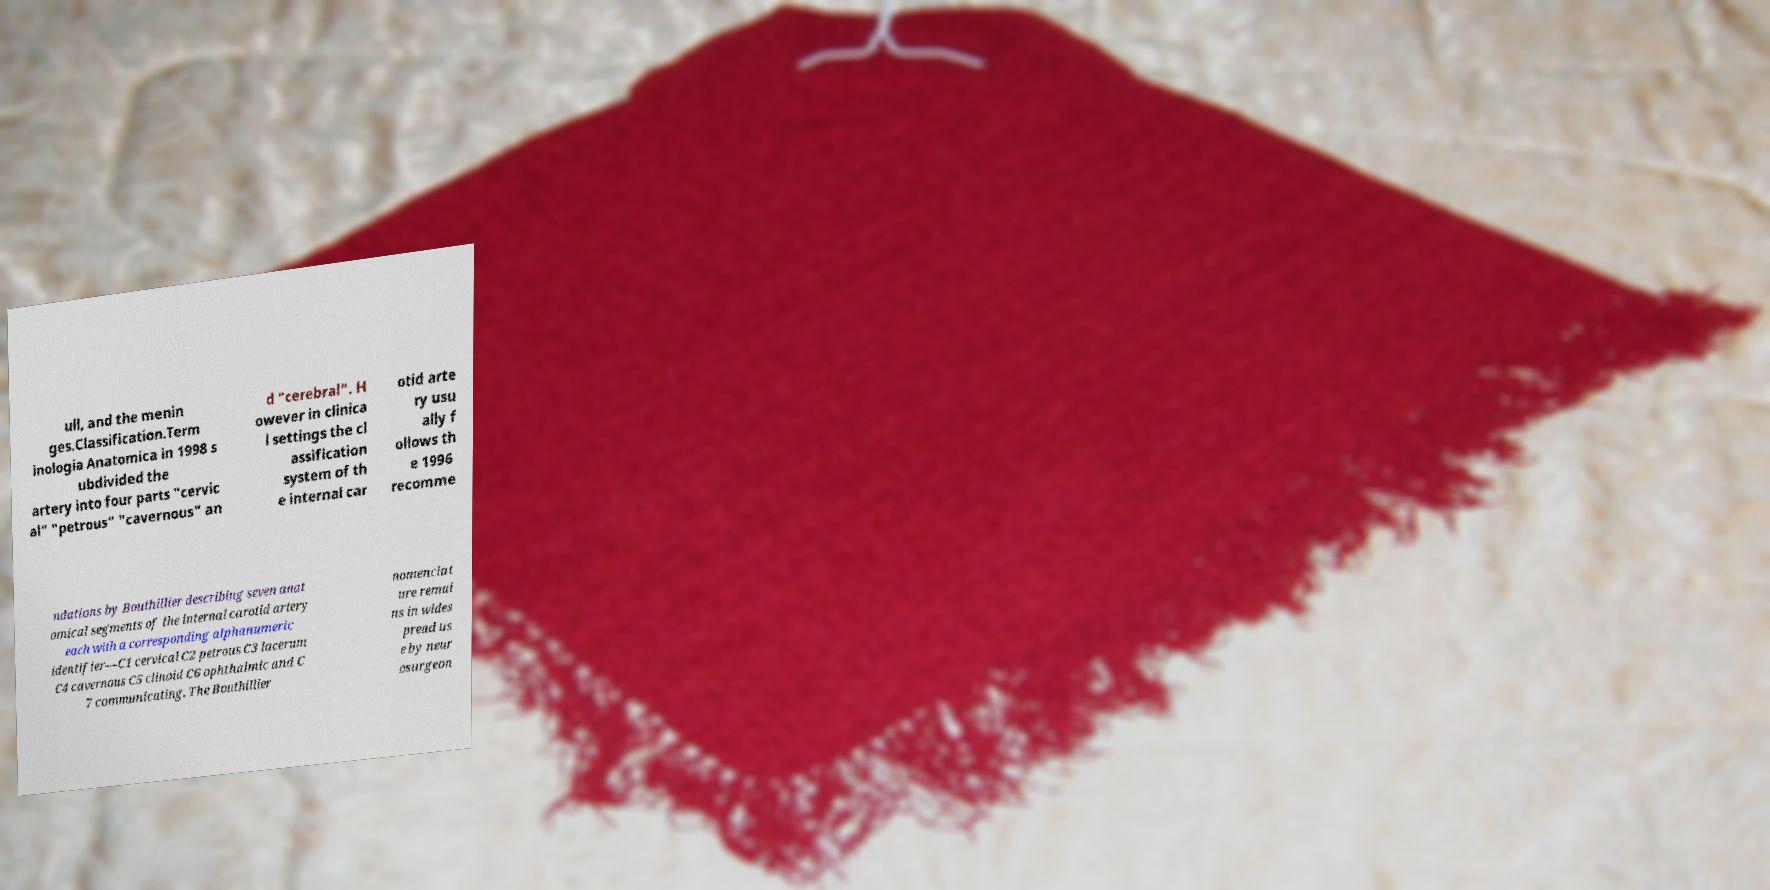Please read and relay the text visible in this image. What does it say? ull, and the menin ges.Classification.Term inologia Anatomica in 1998 s ubdivided the artery into four parts "cervic al" "petrous" "cavernous" an d "cerebral". H owever in clinica l settings the cl assification system of th e internal car otid arte ry usu ally f ollows th e 1996 recomme ndations by Bouthillier describing seven anat omical segments of the internal carotid artery each with a corresponding alphanumeric identifier—C1 cervical C2 petrous C3 lacerum C4 cavernous C5 clinoid C6 ophthalmic and C 7 communicating. The Bouthillier nomenclat ure remai ns in wides pread us e by neur osurgeon 